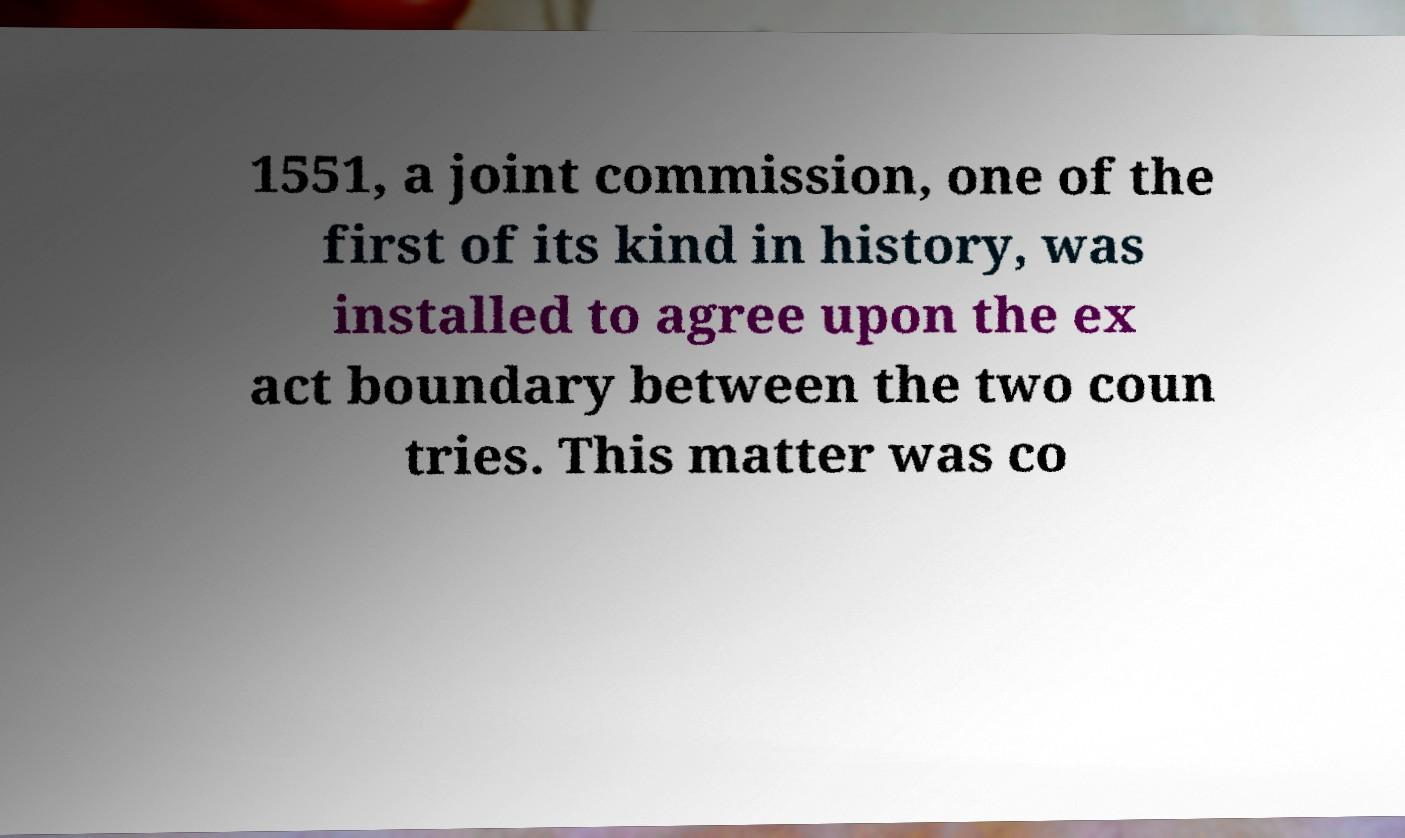I need the written content from this picture converted into text. Can you do that? 1551, a joint commission, one of the first of its kind in history, was installed to agree upon the ex act boundary between the two coun tries. This matter was co 